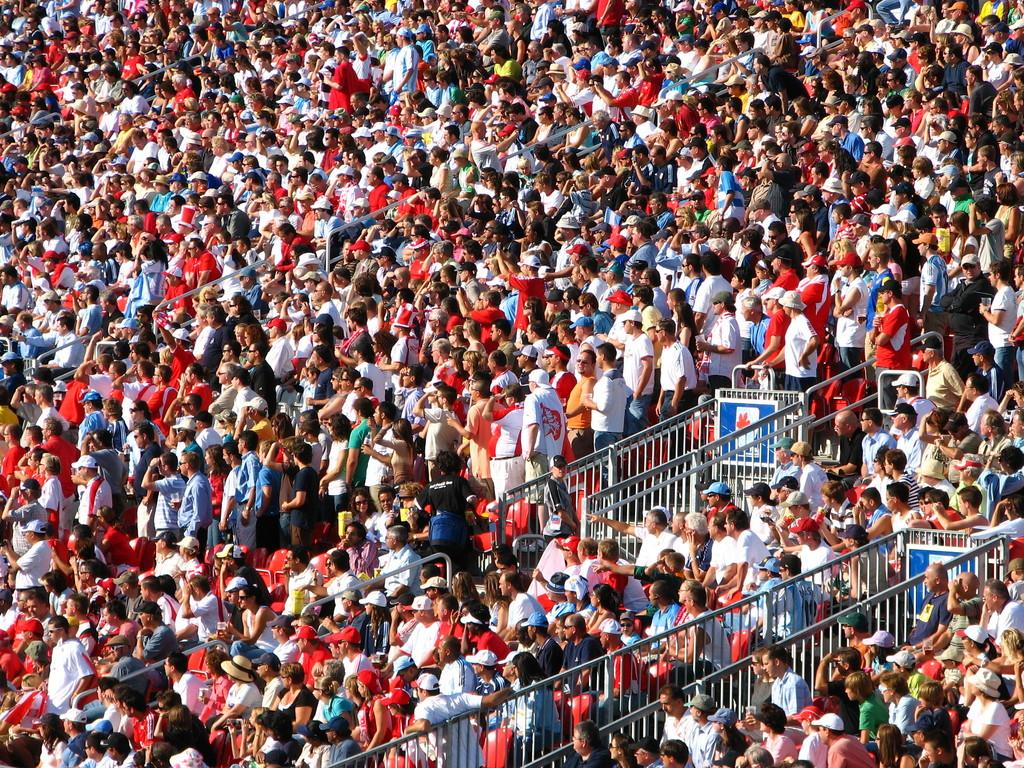What are the people in the image doing? There are people sitting and standing in the image. What can be seen in the middle of the image? There is a railing in the middle of the image. What type of bean is being served in the lunchroom in the image? There is no lunchroom or bean present in the image. Can you describe the bath that the people are taking in the image? There is no bath or people taking a bath in the image. 